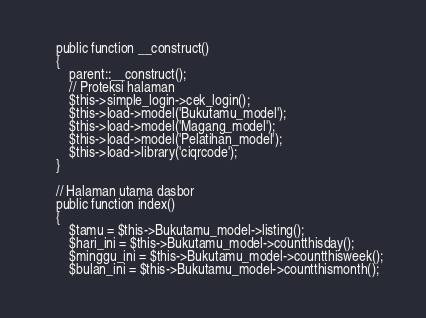<code> <loc_0><loc_0><loc_500><loc_500><_PHP_>	public function __construct()
	{
		parent::__construct();
		// Proteksi halaman
		$this->simple_login->cek_login();
		$this->load->model('Bukutamu_model');
		$this->load->model('Magang_model');
		$this->load->model('Pelatihan_model');
		$this->load->library('ciqrcode');
	}

	// Halaman utama dasbor
	public function index()
	{
		$tamu = $this->Bukutamu_model->listing();
		$hari_ini = $this->Bukutamu_model->countthisday();
		$minggu_ini = $this->Bukutamu_model->countthisweek();
		$bulan_ini = $this->Bukutamu_model->countthismonth();</code> 